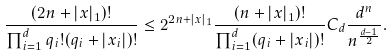Convert formula to latex. <formula><loc_0><loc_0><loc_500><loc_500>\frac { ( 2 n + | x | _ { 1 } ) ! } { \prod _ { i = 1 } ^ { d } q _ { i } ! ( q _ { i } + | x _ { i } | ) ! } \leq 2 ^ { 2 n + | x | _ { 1 } } \frac { ( n + | x | _ { 1 } ) ! } { \prod _ { i = 1 } ^ { d } ( q _ { i } + | x _ { i } | ) ! } C _ { d } \frac { d ^ { n } } { n ^ { \frac { d - 1 } { 2 } } } .</formula> 